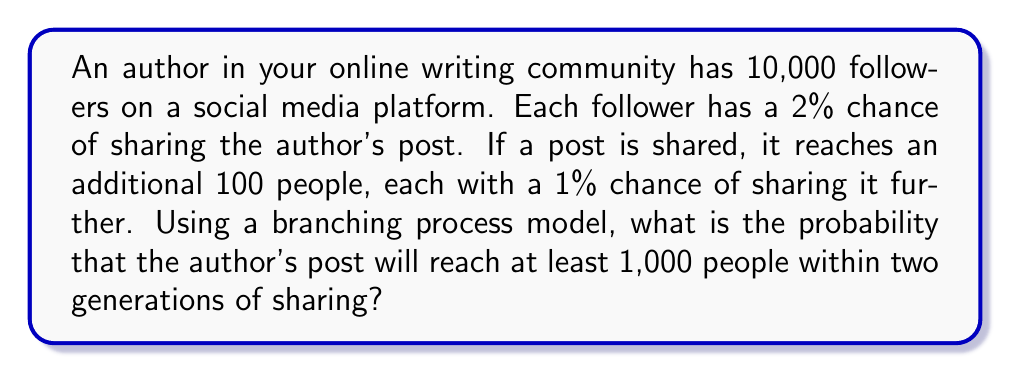Show me your answer to this math problem. Let's approach this step-by-step using a branching process model:

1) First generation:
   - Number of initial followers: $N_0 = 10,000$
   - Probability of sharing: $p_1 = 0.02$
   - Expected number of shares: $\lambda_1 = N_0 \cdot p_1 = 10,000 \cdot 0.02 = 200$

2) Second generation:
   - Each share reaches 100 people
   - Probability of sharing: $p_2 = 0.01$
   - Expected number of shares per first-generation share: $\lambda_2 = 100 \cdot 0.01 = 1$

3) Total expected reach:
   - Initial followers: $10,000$
   - First generation: $200 \cdot 100 = 20,000$
   - Second generation: $200 \cdot 1 \cdot 100 = 20,000$
   - Total expected reach: $10,000 + 20,000 + 20,000 = 50,000$

4) We can model this as a Poisson process. The probability of reaching at least 1,000 people is equivalent to the probability of not reaching fewer than 1,000 people.

5) Let $X$ be the random variable representing the number of people reached. It follows a Poisson distribution with mean $\lambda = 50,000$.

6) We want to calculate $P(X \geq 1000) = 1 - P(X < 1000)$

7) Using the cumulative distribution function of the Poisson distribution:

   $$P(X < 1000) = e^{-\lambda} \sum_{k=0}^{999} \frac{\lambda^k}{k!}$$

8) This can be calculated using software or approximated using the normal distribution for large $\lambda$:

   $$P(X < 1000) \approx \Phi\left(\frac{999.5 - 50000}{\sqrt{50000}}\right)$$

   Where $\Phi$ is the standard normal cumulative distribution function.

9) Using this approximation:
   $$P(X < 1000) \approx \Phi(-219.3) \approx 0$$

10) Therefore, $P(X \geq 1000) = 1 - P(X < 1000) \approx 1 - 0 = 1$
Answer: $\approx 1$ (or 99.99%) 